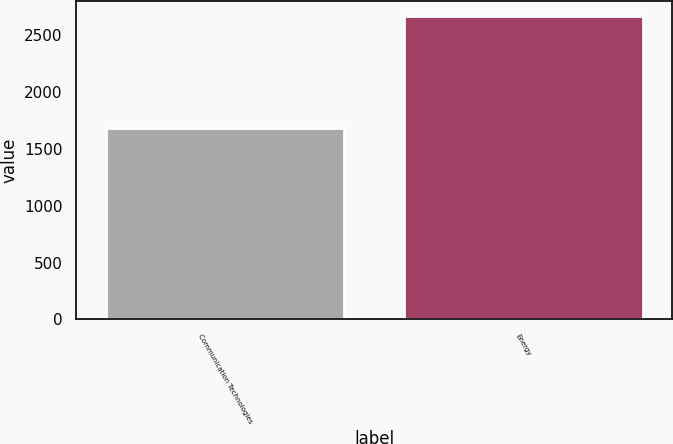<chart> <loc_0><loc_0><loc_500><loc_500><bar_chart><fcel>Communication Technologies<fcel>Energy<nl><fcel>1684<fcel>2668<nl></chart> 